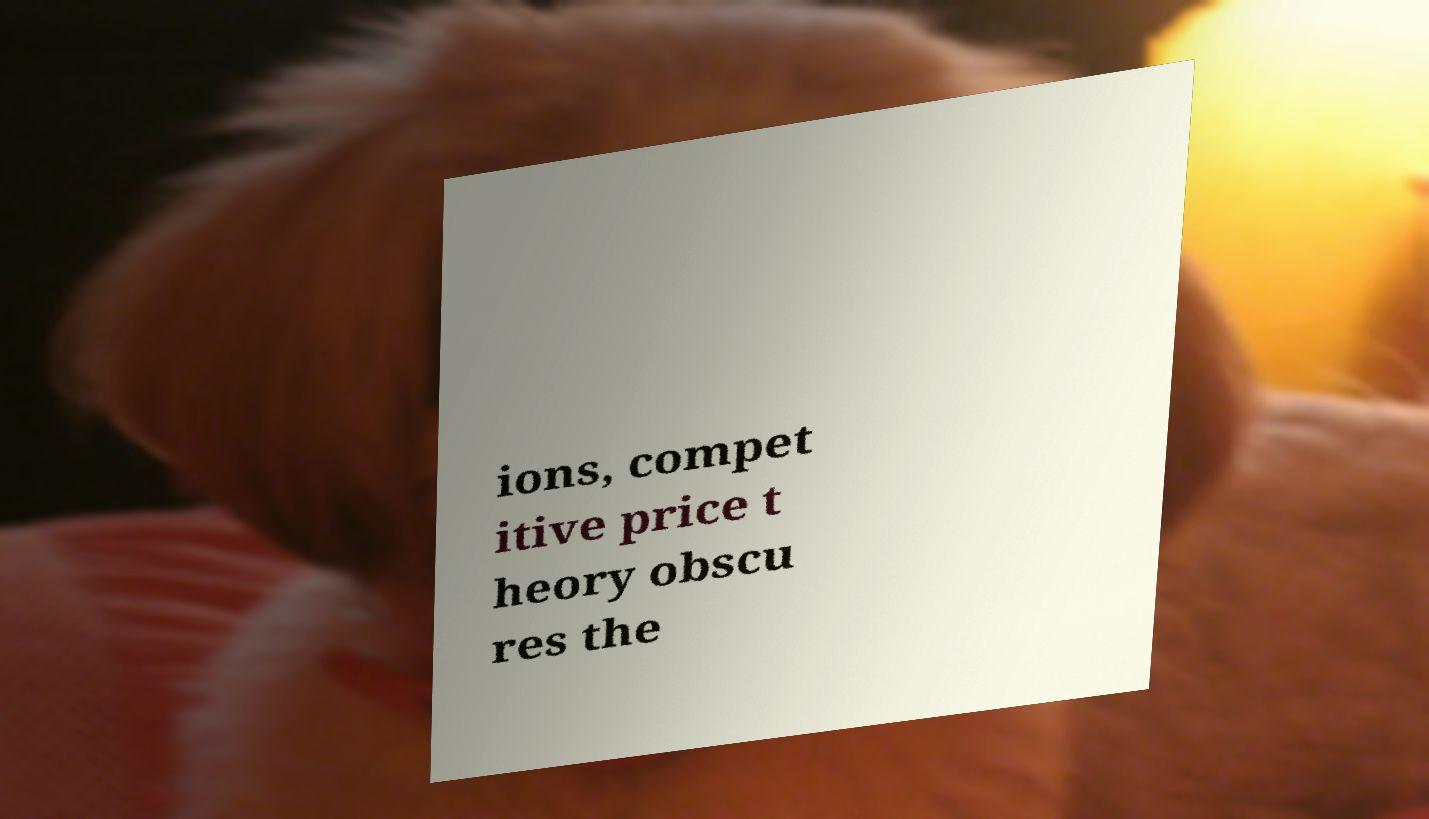Can you read and provide the text displayed in the image?This photo seems to have some interesting text. Can you extract and type it out for me? ions, compet itive price t heory obscu res the 